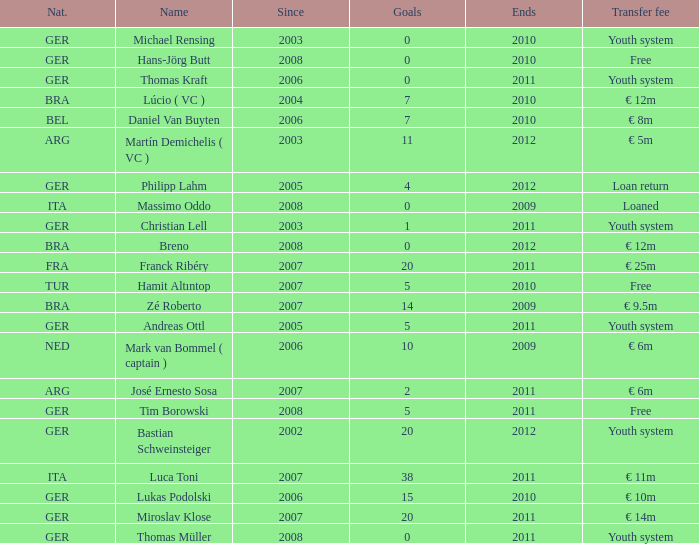What is the lowest year in since that had a transfer fee of € 14m and ended after 2011? None. 